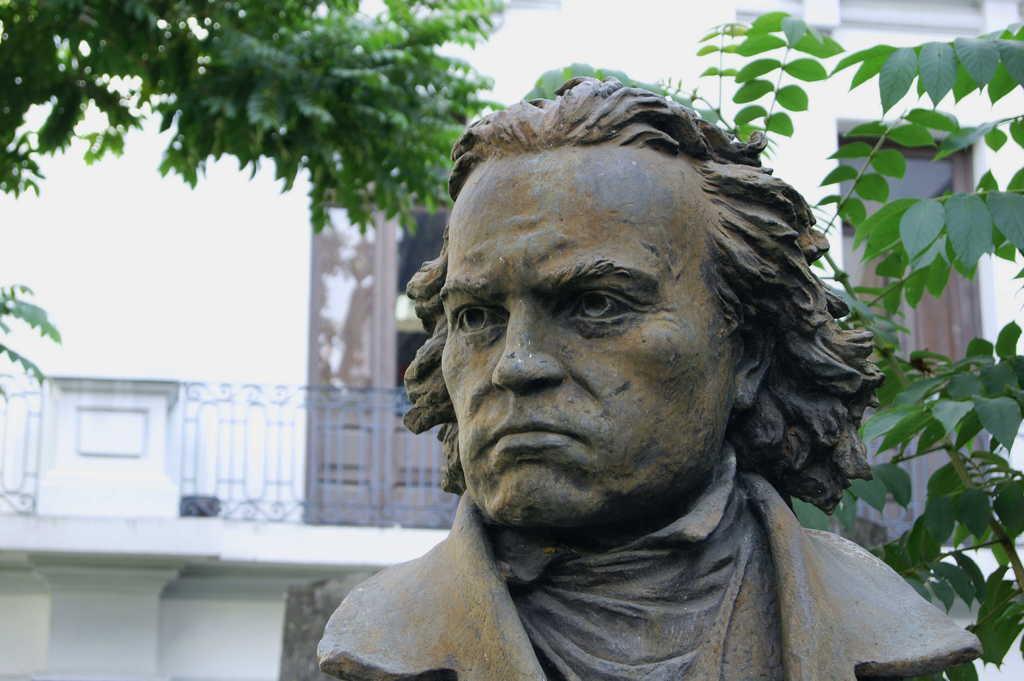Please provide a concise description of this image. In this picture I can see statue of a man and I can see building in the back and I can see couple of trees. 